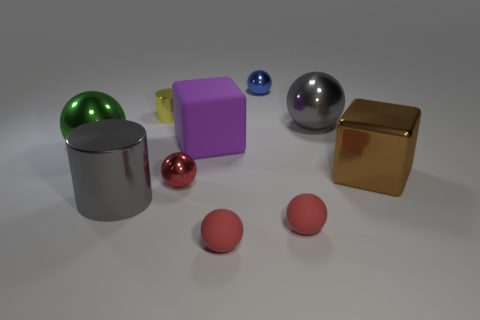How many red balls must be subtracted to get 1 red balls? 2 Subtract all tiny red metal spheres. How many spheres are left? 5 Subtract 5 spheres. How many spheres are left? 1 Subtract all green cylinders. How many blue balls are left? 1 Add 1 red balls. How many red balls are left? 4 Add 4 green matte spheres. How many green matte spheres exist? 4 Subtract all blue spheres. How many spheres are left? 5 Subtract 0 yellow blocks. How many objects are left? 10 Subtract all cylinders. How many objects are left? 8 Subtract all gray cylinders. Subtract all cyan blocks. How many cylinders are left? 1 